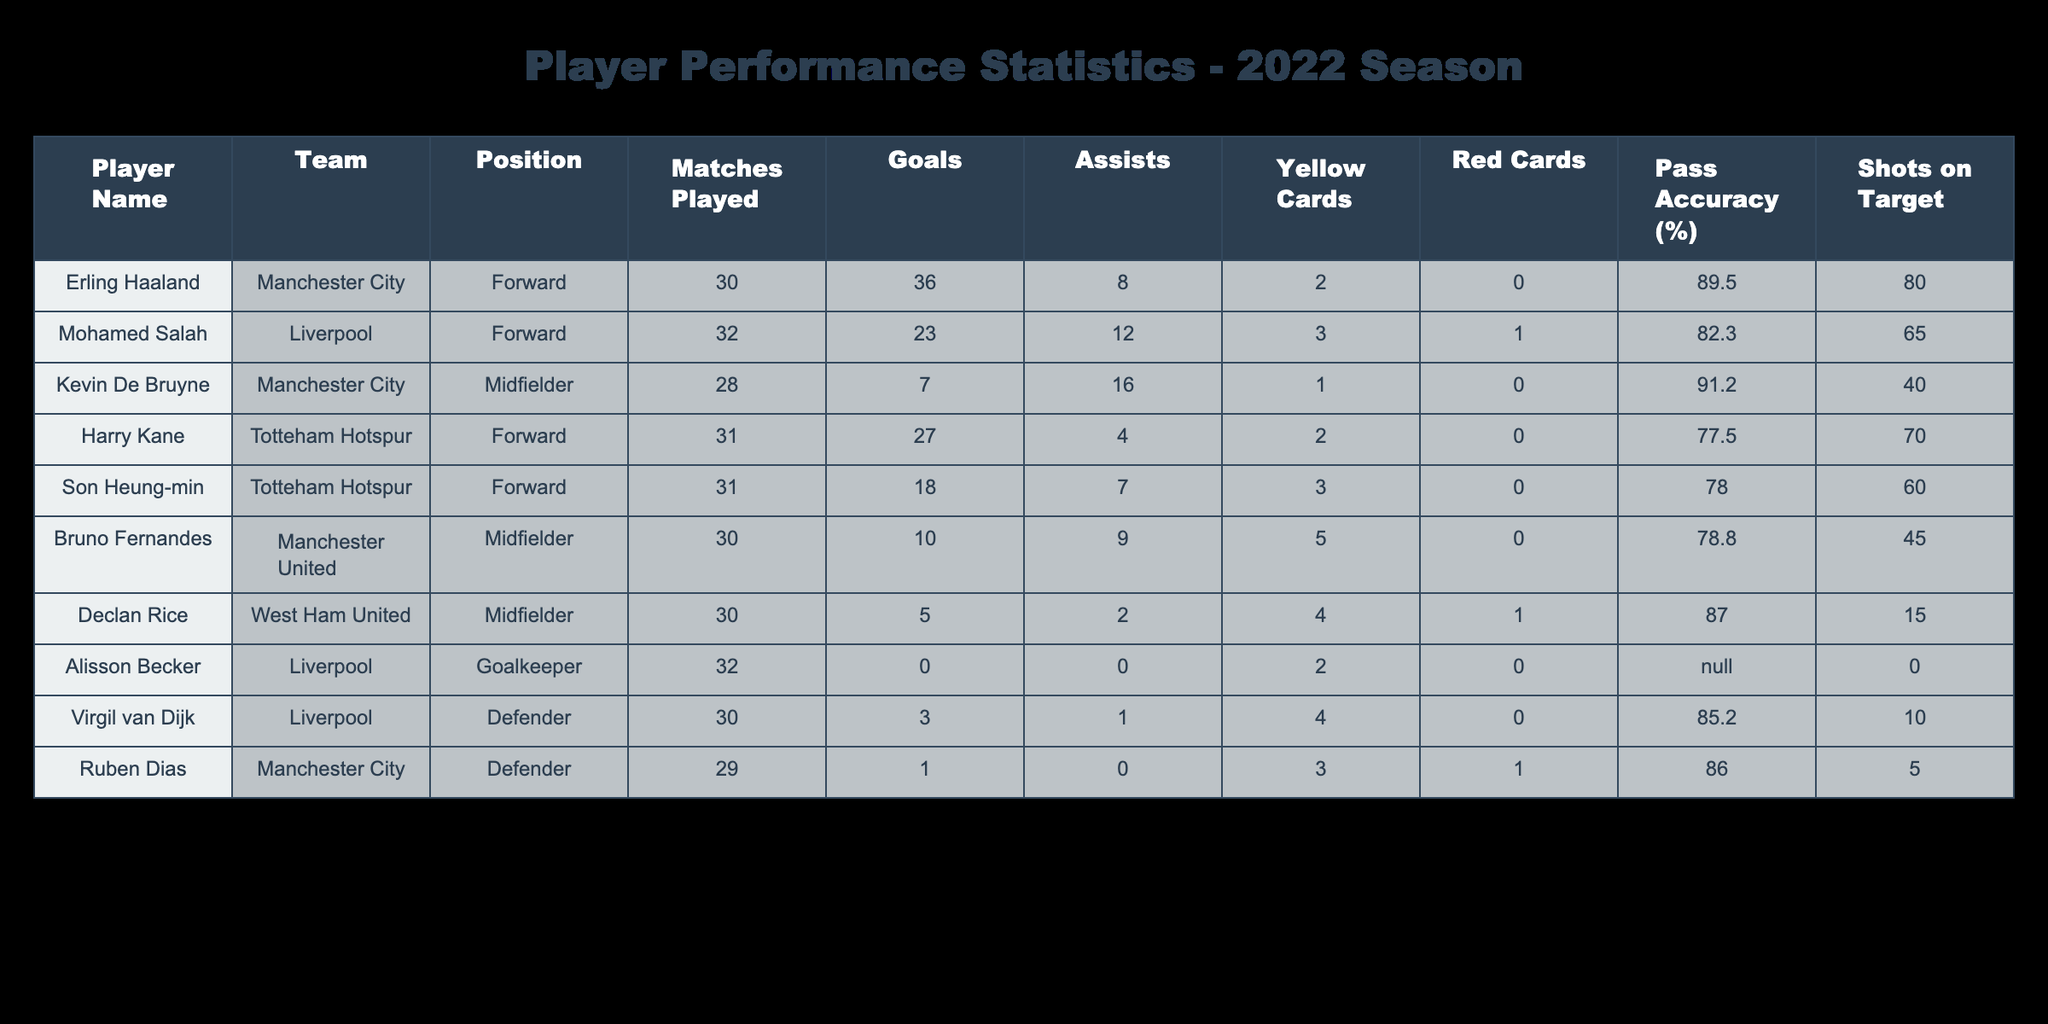What was Erling Haaland's total number of goals in the 2022 season? Erling Haaland is listed in the table with a total of 36 goals. This figure is taken directly from the "Goals" column for his entry.
Answer: 36 Which player had the highest pass accuracy? The table shows that Kevin De Bruyne has a pass accuracy of 91.2%, which is the highest among all players listed in the "Pass Accuracy (%)" column.
Answer: 91.2% How many goals did Mohamed Salah score compared to Kevin De Bruyne? Mohamed Salah scored 23 goals while Kevin De Bruyne scored 7 goals. The difference between them is calculated as 23 - 7 = 16. Thus, Salah scored 16 more goals than De Bruyne.
Answer: 16 Did any player receive more than 2 yellow cards? By examining the "Yellow Cards" column, we see that both Bruno Fernandes (5 yellow cards) and Declan Rice (4 yellow cards) received more than 2 yellow cards. Therefore, the answer is yes.
Answer: Yes What is the average number of assists for players in this table? To find the average, we sum the total assists: 8 + 12 + 16 + 4 + 7 + 9 + 2 + 0 + 1 + 0 = 59. There are 10 players, so we divide the total by 10: 59 ÷ 10 = 5.9.
Answer: 5.9 Who had the most shots on target among the listed players? The "Shots on Target" column indicates that Erling Haaland had the most with 80 shots on target. This can be checked by comparing the numbers in that column for each player.
Answer: 80 Was there a player who did not score any goals? Alisson Becker is listed in the "Goals" column with a 0, indicating he did not score any goals in the season. Therefore, the answer is yes.
Answer: Yes Which player had the lowest pass accuracy? The table indicates that Alisson Becker's pass accuracy is marked as N/A (not applicable), as he is a goalkeeper. Since others have defined values, we can consider that as the lowest.
Answer: N/A 